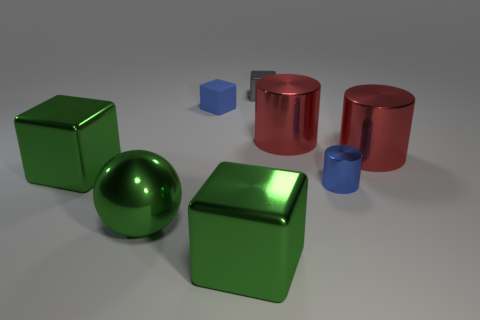Subtract all red cylinders. How many cylinders are left? 1 Add 2 large red metallic things. How many objects exist? 10 Subtract all gray blocks. How many blocks are left? 3 Subtract all red cylinders. Subtract all green spheres. How many cylinders are left? 1 Subtract all gray cylinders. How many blue blocks are left? 1 Subtract all tiny cylinders. Subtract all large green spheres. How many objects are left? 6 Add 2 big red metal cylinders. How many big red metal cylinders are left? 4 Add 3 gray rubber objects. How many gray rubber objects exist? 3 Subtract 1 blue cylinders. How many objects are left? 7 Subtract all cylinders. How many objects are left? 5 